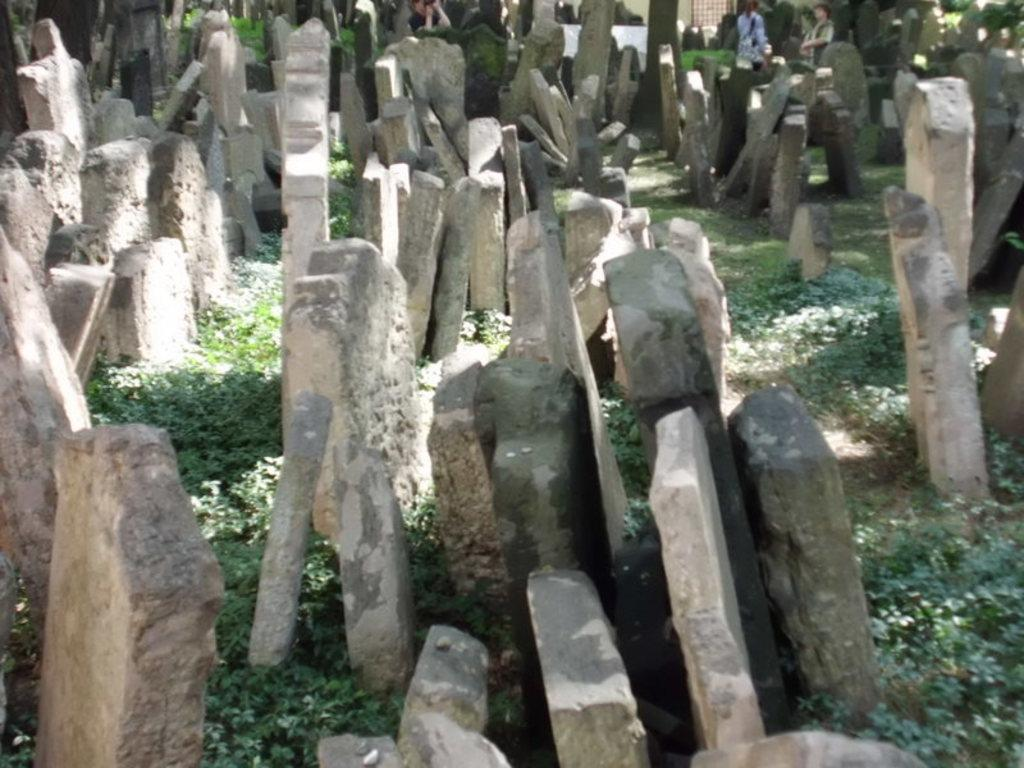What type of objects can be seen at the bottom of the image? There are plants at the bottom of the image. What other objects are present in the image? There are stones in the image. Can you describe the background of the image? There are people in the background of the image. How many bricks are being used to build the net in the image? There is no net or brick present in the image. What type of children's toys can be seen in the image? There is no mention of children or toys in the image. 